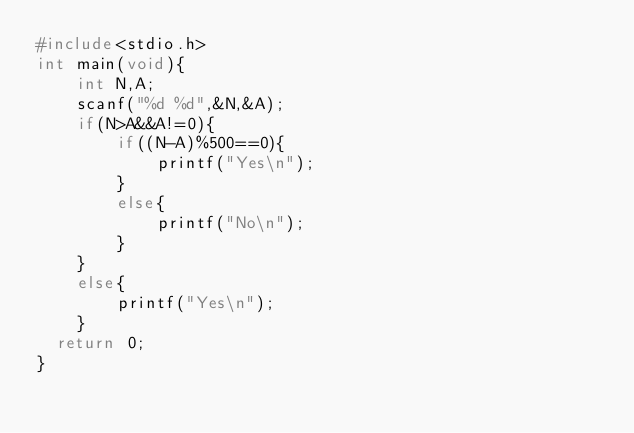Convert code to text. <code><loc_0><loc_0><loc_500><loc_500><_C_>#include<stdio.h>
int main(void){
    int N,A;
    scanf("%d %d",&N,&A);
    if(N>A&&A!=0){
        if((N-A)%500==0){
            printf("Yes\n");
        }
        else{
            printf("No\n");
        }
    }
    else{
        printf("Yes\n");
    }
	return 0;		
}</code> 